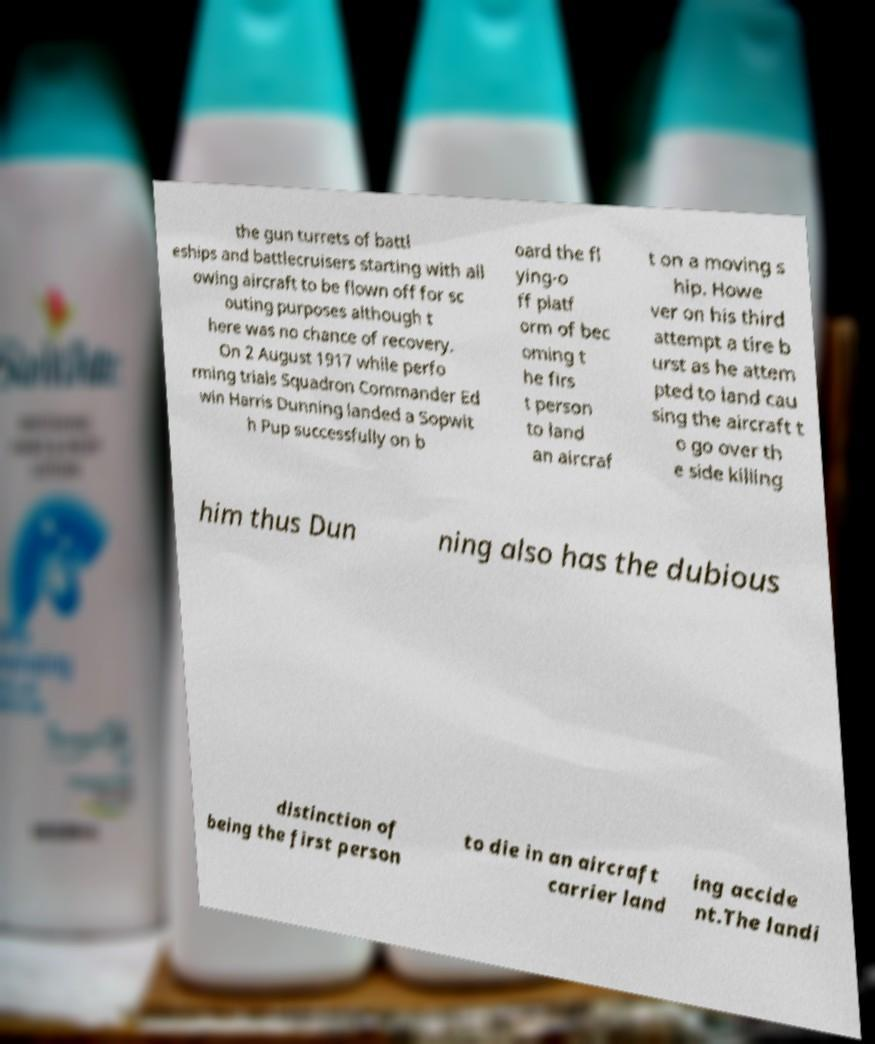There's text embedded in this image that I need extracted. Can you transcribe it verbatim? the gun turrets of battl eships and battlecruisers starting with all owing aircraft to be flown off for sc outing purposes although t here was no chance of recovery. On 2 August 1917 while perfo rming trials Squadron Commander Ed win Harris Dunning landed a Sopwit h Pup successfully on b oard the fl ying-o ff platf orm of bec oming t he firs t person to land an aircraf t on a moving s hip. Howe ver on his third attempt a tire b urst as he attem pted to land cau sing the aircraft t o go over th e side killing him thus Dun ning also has the dubious distinction of being the first person to die in an aircraft carrier land ing accide nt.The landi 